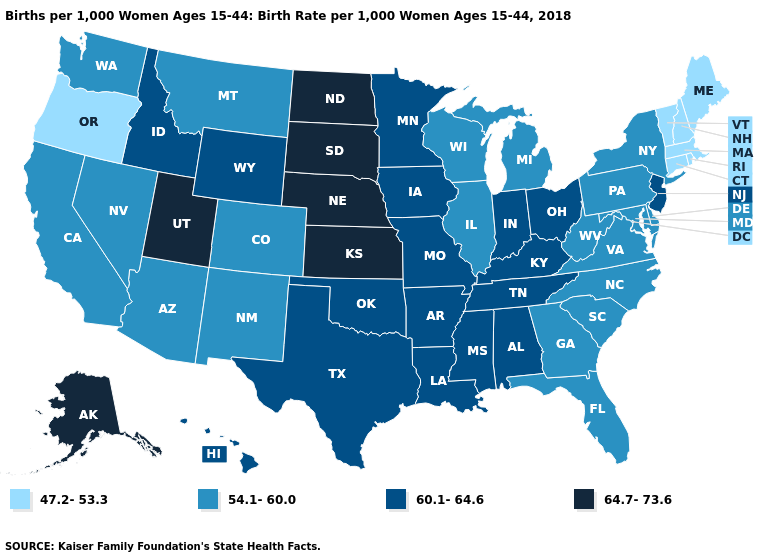Name the states that have a value in the range 60.1-64.6?
Keep it brief. Alabama, Arkansas, Hawaii, Idaho, Indiana, Iowa, Kentucky, Louisiana, Minnesota, Mississippi, Missouri, New Jersey, Ohio, Oklahoma, Tennessee, Texas, Wyoming. Name the states that have a value in the range 47.2-53.3?
Answer briefly. Connecticut, Maine, Massachusetts, New Hampshire, Oregon, Rhode Island, Vermont. Does Illinois have the same value as Connecticut?
Write a very short answer. No. Among the states that border Iowa , which have the lowest value?
Keep it brief. Illinois, Wisconsin. Does Kansas have the highest value in the USA?
Write a very short answer. Yes. Among the states that border California , does Arizona have the highest value?
Concise answer only. Yes. Does Connecticut have the same value as Wisconsin?
Keep it brief. No. What is the value of Pennsylvania?
Write a very short answer. 54.1-60.0. What is the value of Colorado?
Answer briefly. 54.1-60.0. Name the states that have a value in the range 47.2-53.3?
Be succinct. Connecticut, Maine, Massachusetts, New Hampshire, Oregon, Rhode Island, Vermont. Among the states that border California , does Nevada have the lowest value?
Keep it brief. No. Among the states that border Nebraska , does Colorado have the lowest value?
Short answer required. Yes. How many symbols are there in the legend?
Concise answer only. 4. Does Rhode Island have the lowest value in the USA?
Quick response, please. Yes. What is the value of Iowa?
Be succinct. 60.1-64.6. 